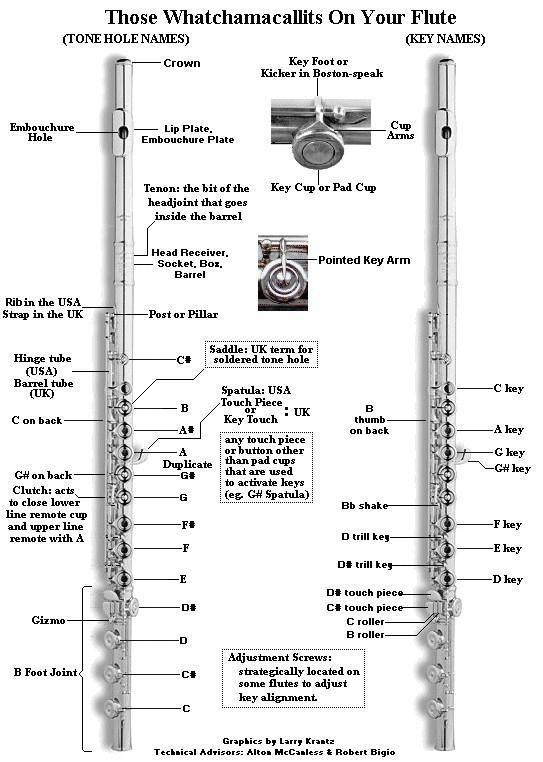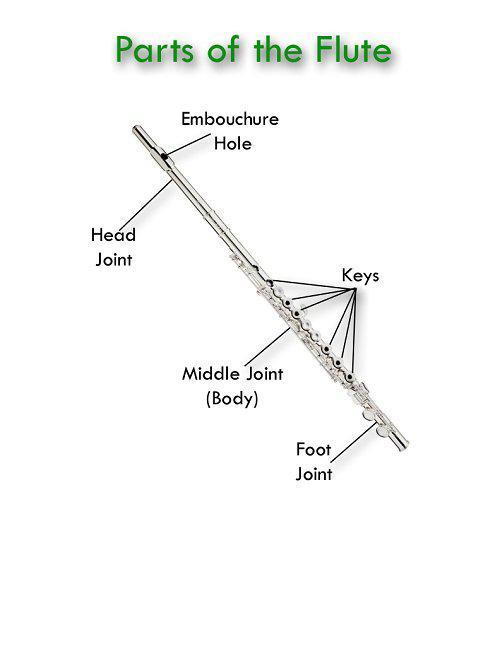The first image is the image on the left, the second image is the image on the right. Evaluate the accuracy of this statement regarding the images: "There are two flute illustrations in the right image.". Is it true? Answer yes or no. No. The first image is the image on the left, the second image is the image on the right. Evaluate the accuracy of this statement regarding the images: "The left and right image contains a total of three flutes.". Is it true? Answer yes or no. Yes. 